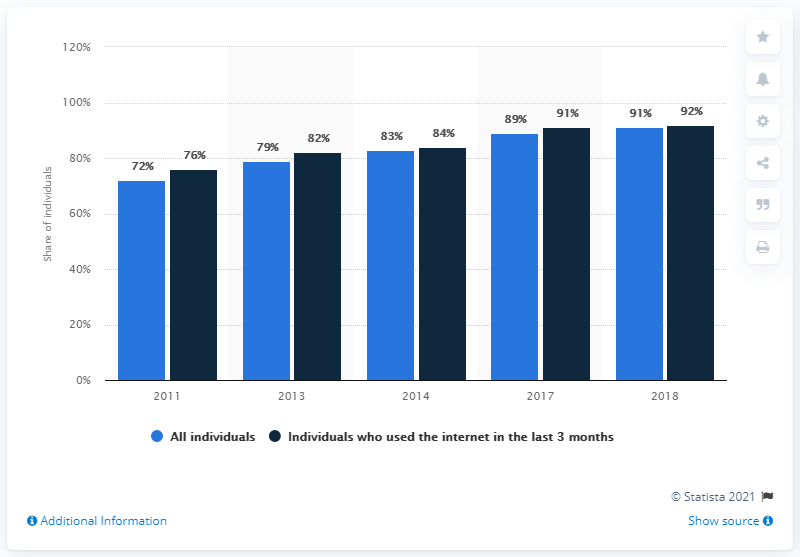Indicate a few pertinent items in this graphic. In 2013, the share of all individuals was 79.. In 2018, the difference between the share of all individuals and the individuals who used the internet in the last 3 months was minimum. 